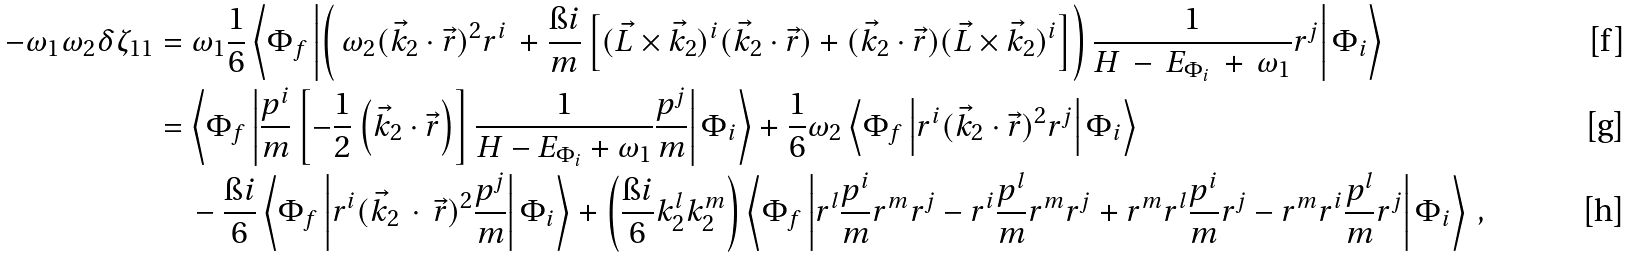<formula> <loc_0><loc_0><loc_500><loc_500>- \omega _ { 1 } \omega _ { 2 } \delta \zeta _ { 1 1 } & = \omega _ { 1 } \frac { 1 } { 6 } \left < \Phi _ { f } \left | \left ( \, \omega _ { 2 } ( \vec { k } _ { 2 } \cdot \vec { r } ) ^ { 2 } r ^ { i } \, + \frac { \i i } { m } \left [ ( \vec { L } \times \vec { k } _ { 2 } ) ^ { i } ( \vec { k } _ { 2 } \cdot \vec { r } ) + ( \vec { k } _ { 2 } \cdot \vec { r } ) ( \vec { L } \times \vec { k } _ { 2 } ) ^ { i } \right ] \right ) \frac { 1 } { H \, - \, E _ { \Phi _ { i } } \, + \, \omega _ { 1 } } r ^ { j } \right | \Phi _ { i } \right > \\ & = \left < \Phi _ { f } \left | \frac { p ^ { i } } { m } \left [ - \frac { 1 } { 2 } \left ( \vec { k } _ { 2 } \cdot \vec { r } \right ) \right ] \frac { 1 } { H - E _ { \Phi _ { i } } + \omega _ { 1 } } \frac { p ^ { j } } { m } \right | \Phi _ { i } \right > + \frac { 1 } { 6 } \omega _ { 2 } \left < \Phi _ { f } \left | r ^ { i } ( \vec { k } _ { 2 } \cdot \vec { r } ) ^ { 2 } r ^ { j } \right | \Phi _ { i } \right > \\ & \quad - \frac { \i i } { 6 } \left < \Phi _ { f } \left | r ^ { i } ( \vec { k } _ { 2 } \, \cdot \, \vec { r } ) ^ { 2 } \frac { p ^ { j } } { m } \right | \Phi _ { i } \right > + \left ( \frac { \i i } { 6 } k ^ { l } _ { 2 } k ^ { m } _ { 2 } \right ) \left < \Phi _ { f } \left | r ^ { l } \frac { p ^ { i } } { m } r ^ { m } r ^ { j } - r ^ { i } \frac { p ^ { l } } { m } r ^ { m } r ^ { j } + r ^ { m } r ^ { l } \frac { p ^ { i } } { m } r ^ { j } - r ^ { m } r ^ { i } \frac { p ^ { l } } { m } r ^ { j } \right | \Phi _ { i } \right > \, ,</formula> 